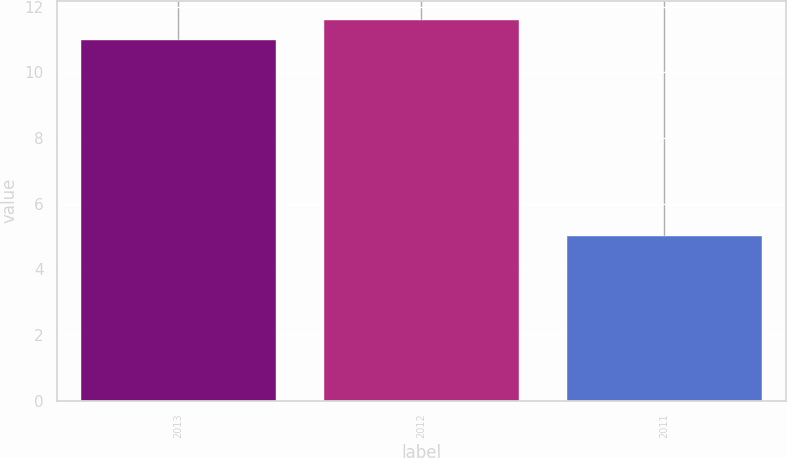Convert chart to OTSL. <chart><loc_0><loc_0><loc_500><loc_500><bar_chart><fcel>2013<fcel>2012<fcel>2011<nl><fcel>11<fcel>11.6<fcel>5<nl></chart> 